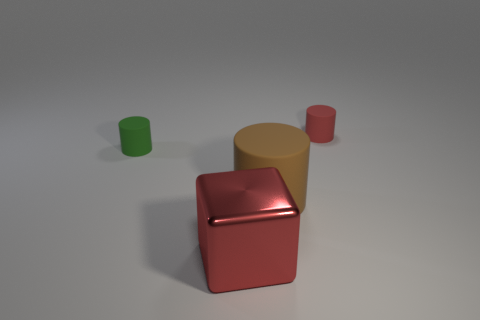Are these objects arranged in any particular pattern or order? The objects are arranged neither in a strict pattern nor random order. They appear deliberately placed with adequate space between them, giving each item its own prominence. It's an organized setup but doesn't seem to follow a rigid geometric pattern. 